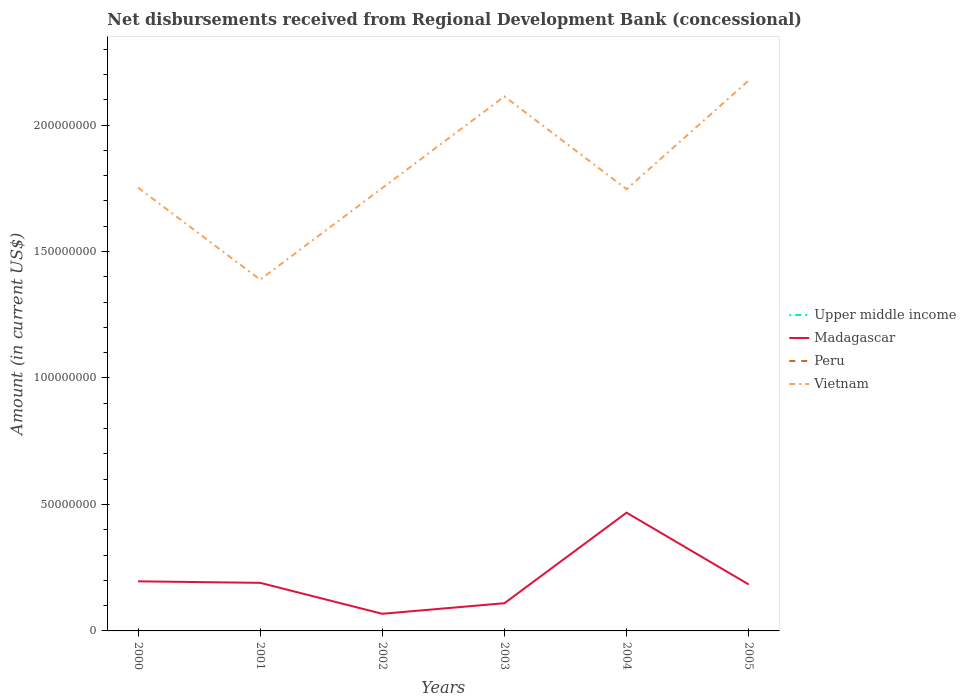How many different coloured lines are there?
Provide a short and direct response. 2. Does the line corresponding to Peru intersect with the line corresponding to Madagascar?
Give a very brief answer. No. Across all years, what is the maximum amount of disbursements received from Regional Development Bank in Madagascar?
Provide a succinct answer. 6.78e+06. What is the total amount of disbursements received from Regional Development Bank in Madagascar in the graph?
Offer a very short reply. 6.38e+05. What is the difference between the highest and the second highest amount of disbursements received from Regional Development Bank in Madagascar?
Your answer should be compact. 4.00e+07. How many lines are there?
Offer a very short reply. 2. How many years are there in the graph?
Your answer should be very brief. 6. What is the difference between two consecutive major ticks on the Y-axis?
Offer a very short reply. 5.00e+07. Are the values on the major ticks of Y-axis written in scientific E-notation?
Your answer should be very brief. No. Does the graph contain any zero values?
Give a very brief answer. Yes. Does the graph contain grids?
Your response must be concise. No. What is the title of the graph?
Provide a succinct answer. Net disbursements received from Regional Development Bank (concessional). What is the Amount (in current US$) in Upper middle income in 2000?
Offer a terse response. 0. What is the Amount (in current US$) in Madagascar in 2000?
Your answer should be compact. 1.96e+07. What is the Amount (in current US$) of Vietnam in 2000?
Ensure brevity in your answer.  1.75e+08. What is the Amount (in current US$) of Upper middle income in 2001?
Keep it short and to the point. 0. What is the Amount (in current US$) in Madagascar in 2001?
Your response must be concise. 1.90e+07. What is the Amount (in current US$) of Vietnam in 2001?
Offer a very short reply. 1.39e+08. What is the Amount (in current US$) in Upper middle income in 2002?
Offer a very short reply. 0. What is the Amount (in current US$) of Madagascar in 2002?
Keep it short and to the point. 6.78e+06. What is the Amount (in current US$) in Vietnam in 2002?
Your answer should be compact. 1.75e+08. What is the Amount (in current US$) in Upper middle income in 2003?
Offer a very short reply. 0. What is the Amount (in current US$) in Madagascar in 2003?
Your answer should be very brief. 1.10e+07. What is the Amount (in current US$) of Vietnam in 2003?
Make the answer very short. 2.11e+08. What is the Amount (in current US$) of Upper middle income in 2004?
Ensure brevity in your answer.  0. What is the Amount (in current US$) of Madagascar in 2004?
Your response must be concise. 4.68e+07. What is the Amount (in current US$) in Vietnam in 2004?
Ensure brevity in your answer.  1.75e+08. What is the Amount (in current US$) in Madagascar in 2005?
Provide a short and direct response. 1.84e+07. What is the Amount (in current US$) of Vietnam in 2005?
Give a very brief answer. 2.18e+08. Across all years, what is the maximum Amount (in current US$) of Madagascar?
Keep it short and to the point. 4.68e+07. Across all years, what is the maximum Amount (in current US$) of Vietnam?
Your response must be concise. 2.18e+08. Across all years, what is the minimum Amount (in current US$) of Madagascar?
Keep it short and to the point. 6.78e+06. Across all years, what is the minimum Amount (in current US$) in Vietnam?
Give a very brief answer. 1.39e+08. What is the total Amount (in current US$) in Madagascar in the graph?
Make the answer very short. 1.21e+08. What is the total Amount (in current US$) in Peru in the graph?
Provide a succinct answer. 0. What is the total Amount (in current US$) of Vietnam in the graph?
Your answer should be compact. 1.09e+09. What is the difference between the Amount (in current US$) in Madagascar in 2000 and that in 2001?
Offer a terse response. 6.00e+05. What is the difference between the Amount (in current US$) in Vietnam in 2000 and that in 2001?
Ensure brevity in your answer.  3.64e+07. What is the difference between the Amount (in current US$) of Madagascar in 2000 and that in 2002?
Offer a terse response. 1.28e+07. What is the difference between the Amount (in current US$) in Vietnam in 2000 and that in 2002?
Offer a very short reply. 1.56e+05. What is the difference between the Amount (in current US$) in Madagascar in 2000 and that in 2003?
Your answer should be compact. 8.65e+06. What is the difference between the Amount (in current US$) of Vietnam in 2000 and that in 2003?
Provide a succinct answer. -3.60e+07. What is the difference between the Amount (in current US$) of Madagascar in 2000 and that in 2004?
Ensure brevity in your answer.  -2.71e+07. What is the difference between the Amount (in current US$) in Vietnam in 2000 and that in 2004?
Offer a very short reply. 6.31e+05. What is the difference between the Amount (in current US$) in Madagascar in 2000 and that in 2005?
Offer a terse response. 1.24e+06. What is the difference between the Amount (in current US$) in Vietnam in 2000 and that in 2005?
Offer a very short reply. -4.23e+07. What is the difference between the Amount (in current US$) of Madagascar in 2001 and that in 2002?
Provide a short and direct response. 1.22e+07. What is the difference between the Amount (in current US$) of Vietnam in 2001 and that in 2002?
Ensure brevity in your answer.  -3.62e+07. What is the difference between the Amount (in current US$) of Madagascar in 2001 and that in 2003?
Your answer should be compact. 8.05e+06. What is the difference between the Amount (in current US$) of Vietnam in 2001 and that in 2003?
Offer a terse response. -7.24e+07. What is the difference between the Amount (in current US$) of Madagascar in 2001 and that in 2004?
Make the answer very short. -2.77e+07. What is the difference between the Amount (in current US$) in Vietnam in 2001 and that in 2004?
Offer a very short reply. -3.58e+07. What is the difference between the Amount (in current US$) in Madagascar in 2001 and that in 2005?
Your answer should be very brief. 6.38e+05. What is the difference between the Amount (in current US$) of Vietnam in 2001 and that in 2005?
Your answer should be compact. -7.87e+07. What is the difference between the Amount (in current US$) of Madagascar in 2002 and that in 2003?
Your response must be concise. -4.18e+06. What is the difference between the Amount (in current US$) in Vietnam in 2002 and that in 2003?
Ensure brevity in your answer.  -3.62e+07. What is the difference between the Amount (in current US$) in Madagascar in 2002 and that in 2004?
Offer a terse response. -4.00e+07. What is the difference between the Amount (in current US$) in Vietnam in 2002 and that in 2004?
Give a very brief answer. 4.75e+05. What is the difference between the Amount (in current US$) of Madagascar in 2002 and that in 2005?
Your answer should be very brief. -1.16e+07. What is the difference between the Amount (in current US$) in Vietnam in 2002 and that in 2005?
Your answer should be very brief. -4.25e+07. What is the difference between the Amount (in current US$) in Madagascar in 2003 and that in 2004?
Your answer should be very brief. -3.58e+07. What is the difference between the Amount (in current US$) of Vietnam in 2003 and that in 2004?
Your answer should be compact. 3.67e+07. What is the difference between the Amount (in current US$) in Madagascar in 2003 and that in 2005?
Ensure brevity in your answer.  -7.41e+06. What is the difference between the Amount (in current US$) in Vietnam in 2003 and that in 2005?
Your answer should be compact. -6.31e+06. What is the difference between the Amount (in current US$) in Madagascar in 2004 and that in 2005?
Make the answer very short. 2.84e+07. What is the difference between the Amount (in current US$) of Vietnam in 2004 and that in 2005?
Offer a very short reply. -4.30e+07. What is the difference between the Amount (in current US$) in Madagascar in 2000 and the Amount (in current US$) in Vietnam in 2001?
Offer a terse response. -1.19e+08. What is the difference between the Amount (in current US$) of Madagascar in 2000 and the Amount (in current US$) of Vietnam in 2002?
Ensure brevity in your answer.  -1.56e+08. What is the difference between the Amount (in current US$) in Madagascar in 2000 and the Amount (in current US$) in Vietnam in 2003?
Make the answer very short. -1.92e+08. What is the difference between the Amount (in current US$) in Madagascar in 2000 and the Amount (in current US$) in Vietnam in 2004?
Provide a short and direct response. -1.55e+08. What is the difference between the Amount (in current US$) of Madagascar in 2000 and the Amount (in current US$) of Vietnam in 2005?
Your answer should be very brief. -1.98e+08. What is the difference between the Amount (in current US$) in Madagascar in 2001 and the Amount (in current US$) in Vietnam in 2002?
Your answer should be very brief. -1.56e+08. What is the difference between the Amount (in current US$) of Madagascar in 2001 and the Amount (in current US$) of Vietnam in 2003?
Provide a short and direct response. -1.92e+08. What is the difference between the Amount (in current US$) in Madagascar in 2001 and the Amount (in current US$) in Vietnam in 2004?
Provide a short and direct response. -1.56e+08. What is the difference between the Amount (in current US$) of Madagascar in 2001 and the Amount (in current US$) of Vietnam in 2005?
Offer a very short reply. -1.99e+08. What is the difference between the Amount (in current US$) of Madagascar in 2002 and the Amount (in current US$) of Vietnam in 2003?
Ensure brevity in your answer.  -2.05e+08. What is the difference between the Amount (in current US$) in Madagascar in 2002 and the Amount (in current US$) in Vietnam in 2004?
Offer a very short reply. -1.68e+08. What is the difference between the Amount (in current US$) of Madagascar in 2002 and the Amount (in current US$) of Vietnam in 2005?
Provide a short and direct response. -2.11e+08. What is the difference between the Amount (in current US$) of Madagascar in 2003 and the Amount (in current US$) of Vietnam in 2004?
Offer a terse response. -1.64e+08. What is the difference between the Amount (in current US$) in Madagascar in 2003 and the Amount (in current US$) in Vietnam in 2005?
Offer a very short reply. -2.07e+08. What is the difference between the Amount (in current US$) of Madagascar in 2004 and the Amount (in current US$) of Vietnam in 2005?
Your answer should be compact. -1.71e+08. What is the average Amount (in current US$) in Madagascar per year?
Your response must be concise. 2.02e+07. What is the average Amount (in current US$) in Peru per year?
Ensure brevity in your answer.  0. What is the average Amount (in current US$) of Vietnam per year?
Your answer should be very brief. 1.82e+08. In the year 2000, what is the difference between the Amount (in current US$) of Madagascar and Amount (in current US$) of Vietnam?
Your answer should be very brief. -1.56e+08. In the year 2001, what is the difference between the Amount (in current US$) of Madagascar and Amount (in current US$) of Vietnam?
Offer a terse response. -1.20e+08. In the year 2002, what is the difference between the Amount (in current US$) of Madagascar and Amount (in current US$) of Vietnam?
Ensure brevity in your answer.  -1.68e+08. In the year 2003, what is the difference between the Amount (in current US$) in Madagascar and Amount (in current US$) in Vietnam?
Give a very brief answer. -2.00e+08. In the year 2004, what is the difference between the Amount (in current US$) in Madagascar and Amount (in current US$) in Vietnam?
Your answer should be compact. -1.28e+08. In the year 2005, what is the difference between the Amount (in current US$) in Madagascar and Amount (in current US$) in Vietnam?
Make the answer very short. -1.99e+08. What is the ratio of the Amount (in current US$) of Madagascar in 2000 to that in 2001?
Ensure brevity in your answer.  1.03. What is the ratio of the Amount (in current US$) in Vietnam in 2000 to that in 2001?
Ensure brevity in your answer.  1.26. What is the ratio of the Amount (in current US$) of Madagascar in 2000 to that in 2002?
Your answer should be compact. 2.89. What is the ratio of the Amount (in current US$) of Madagascar in 2000 to that in 2003?
Make the answer very short. 1.79. What is the ratio of the Amount (in current US$) of Vietnam in 2000 to that in 2003?
Your answer should be compact. 0.83. What is the ratio of the Amount (in current US$) in Madagascar in 2000 to that in 2004?
Your answer should be compact. 0.42. What is the ratio of the Amount (in current US$) of Madagascar in 2000 to that in 2005?
Provide a short and direct response. 1.07. What is the ratio of the Amount (in current US$) of Vietnam in 2000 to that in 2005?
Offer a terse response. 0.81. What is the ratio of the Amount (in current US$) of Madagascar in 2001 to that in 2002?
Your answer should be compact. 2.81. What is the ratio of the Amount (in current US$) in Vietnam in 2001 to that in 2002?
Ensure brevity in your answer.  0.79. What is the ratio of the Amount (in current US$) in Madagascar in 2001 to that in 2003?
Offer a terse response. 1.73. What is the ratio of the Amount (in current US$) in Vietnam in 2001 to that in 2003?
Your response must be concise. 0.66. What is the ratio of the Amount (in current US$) of Madagascar in 2001 to that in 2004?
Keep it short and to the point. 0.41. What is the ratio of the Amount (in current US$) in Vietnam in 2001 to that in 2004?
Keep it short and to the point. 0.8. What is the ratio of the Amount (in current US$) in Madagascar in 2001 to that in 2005?
Your answer should be very brief. 1.03. What is the ratio of the Amount (in current US$) in Vietnam in 2001 to that in 2005?
Provide a succinct answer. 0.64. What is the ratio of the Amount (in current US$) of Madagascar in 2002 to that in 2003?
Provide a succinct answer. 0.62. What is the ratio of the Amount (in current US$) in Vietnam in 2002 to that in 2003?
Your response must be concise. 0.83. What is the ratio of the Amount (in current US$) of Madagascar in 2002 to that in 2004?
Your answer should be compact. 0.14. What is the ratio of the Amount (in current US$) in Vietnam in 2002 to that in 2004?
Give a very brief answer. 1. What is the ratio of the Amount (in current US$) of Madagascar in 2002 to that in 2005?
Provide a short and direct response. 0.37. What is the ratio of the Amount (in current US$) in Vietnam in 2002 to that in 2005?
Provide a succinct answer. 0.8. What is the ratio of the Amount (in current US$) in Madagascar in 2003 to that in 2004?
Your response must be concise. 0.23. What is the ratio of the Amount (in current US$) of Vietnam in 2003 to that in 2004?
Provide a succinct answer. 1.21. What is the ratio of the Amount (in current US$) in Madagascar in 2003 to that in 2005?
Make the answer very short. 0.6. What is the ratio of the Amount (in current US$) of Vietnam in 2003 to that in 2005?
Make the answer very short. 0.97. What is the ratio of the Amount (in current US$) in Madagascar in 2004 to that in 2005?
Provide a short and direct response. 2.55. What is the ratio of the Amount (in current US$) of Vietnam in 2004 to that in 2005?
Keep it short and to the point. 0.8. What is the difference between the highest and the second highest Amount (in current US$) in Madagascar?
Offer a terse response. 2.71e+07. What is the difference between the highest and the second highest Amount (in current US$) in Vietnam?
Give a very brief answer. 6.31e+06. What is the difference between the highest and the lowest Amount (in current US$) in Madagascar?
Provide a succinct answer. 4.00e+07. What is the difference between the highest and the lowest Amount (in current US$) of Vietnam?
Your response must be concise. 7.87e+07. 